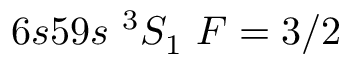<formula> <loc_0><loc_0><loc_500><loc_500>6 s 5 9 s ^ { 3 } S _ { 1 } F = 3 / 2</formula> 